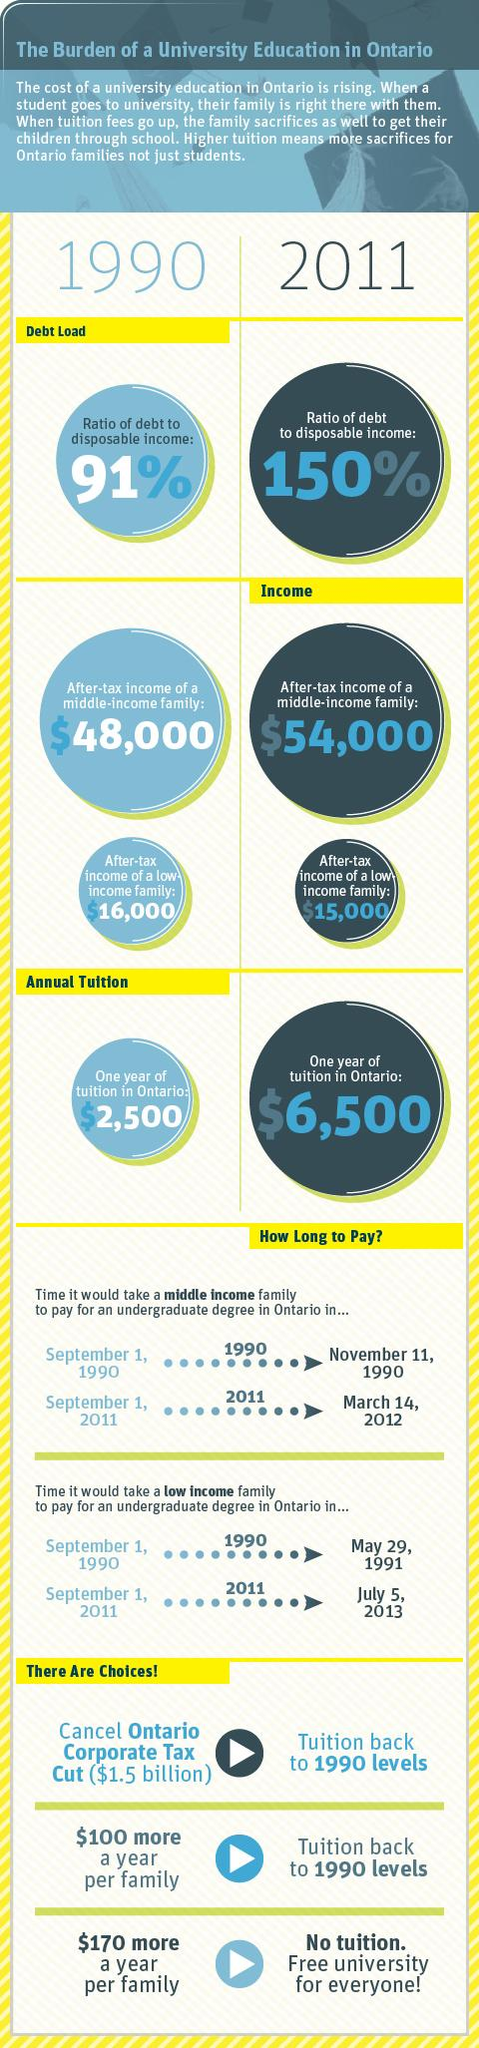List a handful of essential elements in this visual. In 1990, the after-tax income of a middle income family was higher than that of a low income family by $32,000. In 2011, the after-tax income of a middle-income family was approximately $54,000. The decrease in the after-tax income of a low-income family over 21 years is approximately $1,000. In 1990, the ratio of debt to disposable income was lower compared to other years. In the year 1990, the tuition fee in Ontario was $2,500. 